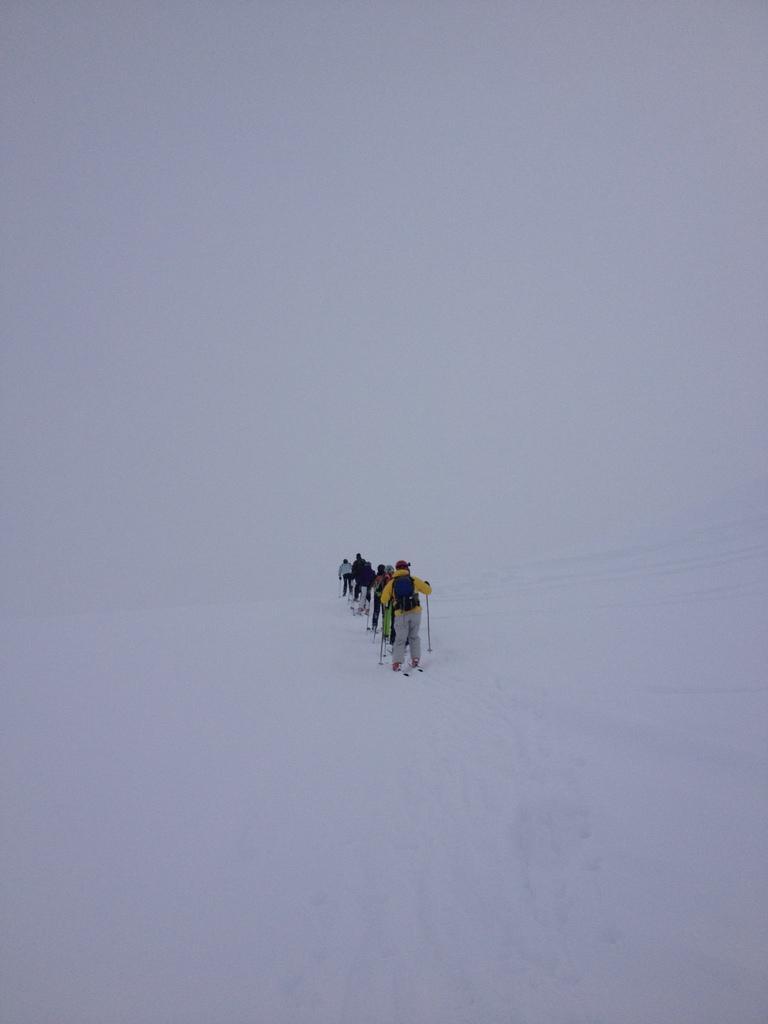Please provide a concise description of this image. In the center of the image we can see the people skiing on the snow. 